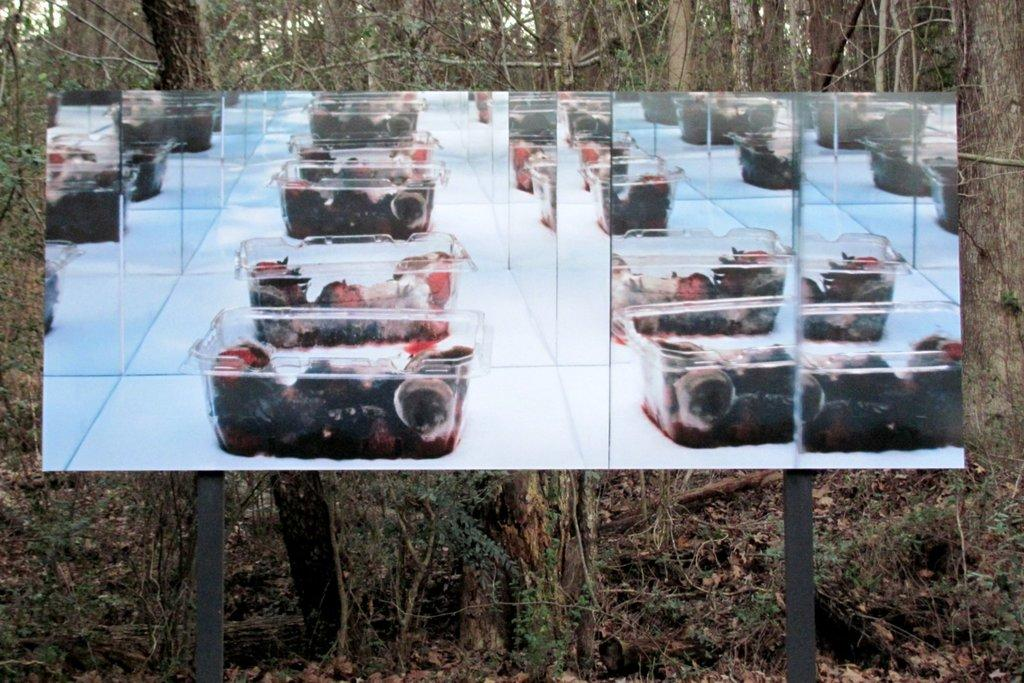What is the main structure in the image? There is a board on poles in the image. What is displayed on the board? The board has boxes with fruits. What can be seen in the distance in the image? There are trees in the background of the image. How many lawyers are present in the image? There are no lawyers present in the image. What type of pail can be seen being used by the women in the image? There are no women or pails present in the image. 